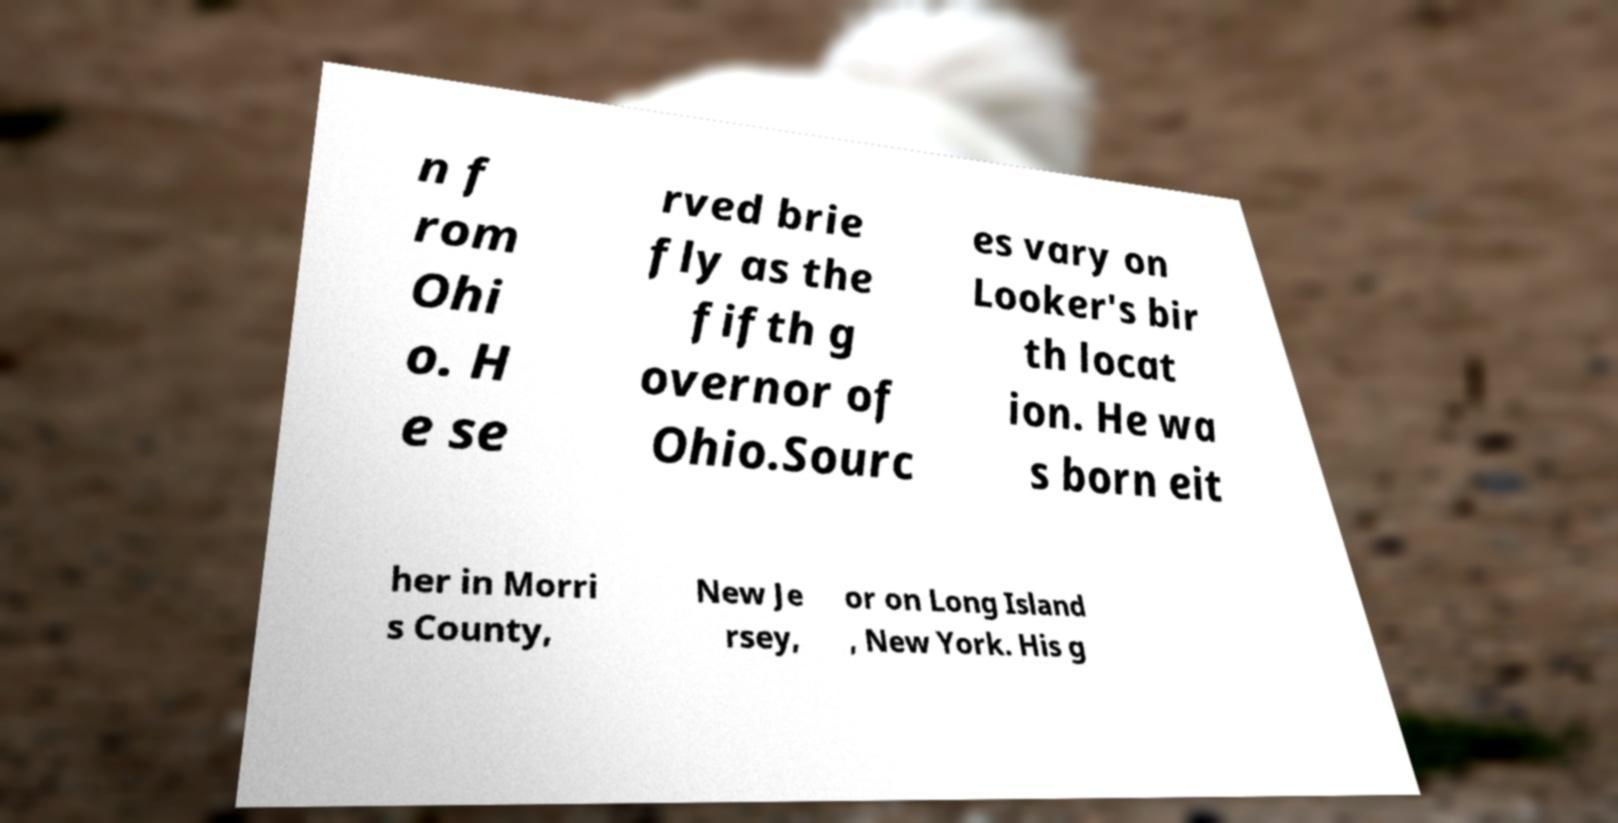What messages or text are displayed in this image? I need them in a readable, typed format. n f rom Ohi o. H e se rved brie fly as the fifth g overnor of Ohio.Sourc es vary on Looker's bir th locat ion. He wa s born eit her in Morri s County, New Je rsey, or on Long Island , New York. His g 